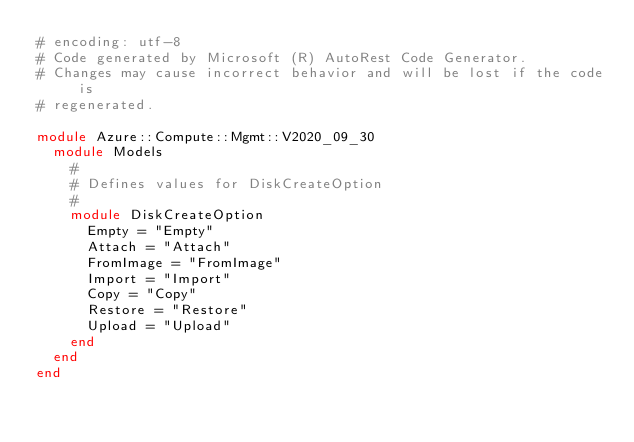Convert code to text. <code><loc_0><loc_0><loc_500><loc_500><_Ruby_># encoding: utf-8
# Code generated by Microsoft (R) AutoRest Code Generator.
# Changes may cause incorrect behavior and will be lost if the code is
# regenerated.

module Azure::Compute::Mgmt::V2020_09_30
  module Models
    #
    # Defines values for DiskCreateOption
    #
    module DiskCreateOption
      Empty = "Empty"
      Attach = "Attach"
      FromImage = "FromImage"
      Import = "Import"
      Copy = "Copy"
      Restore = "Restore"
      Upload = "Upload"
    end
  end
end
</code> 